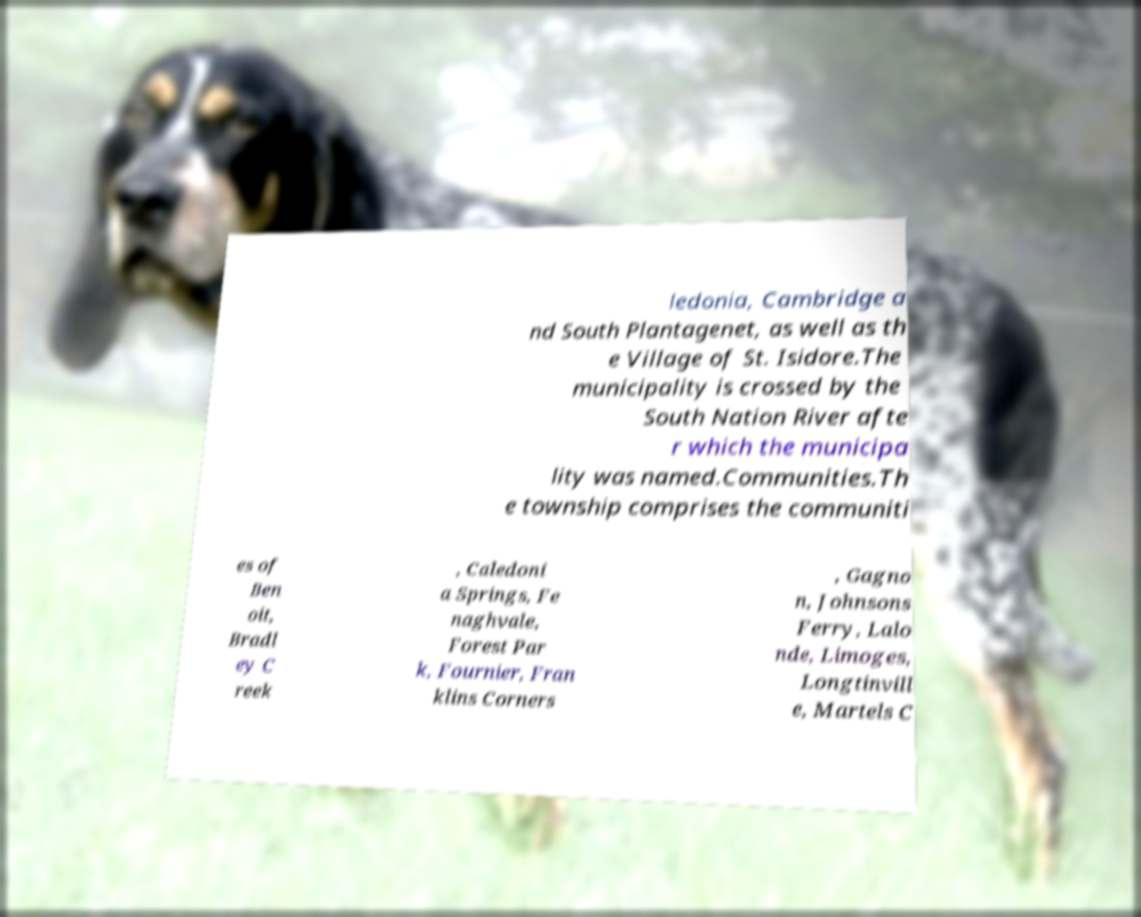Please read and relay the text visible in this image. What does it say? ledonia, Cambridge a nd South Plantagenet, as well as th e Village of St. Isidore.The municipality is crossed by the South Nation River afte r which the municipa lity was named.Communities.Th e township comprises the communiti es of Ben oit, Bradl ey C reek , Caledoni a Springs, Fe naghvale, Forest Par k, Fournier, Fran klins Corners , Gagno n, Johnsons Ferry, Lalo nde, Limoges, Longtinvill e, Martels C 